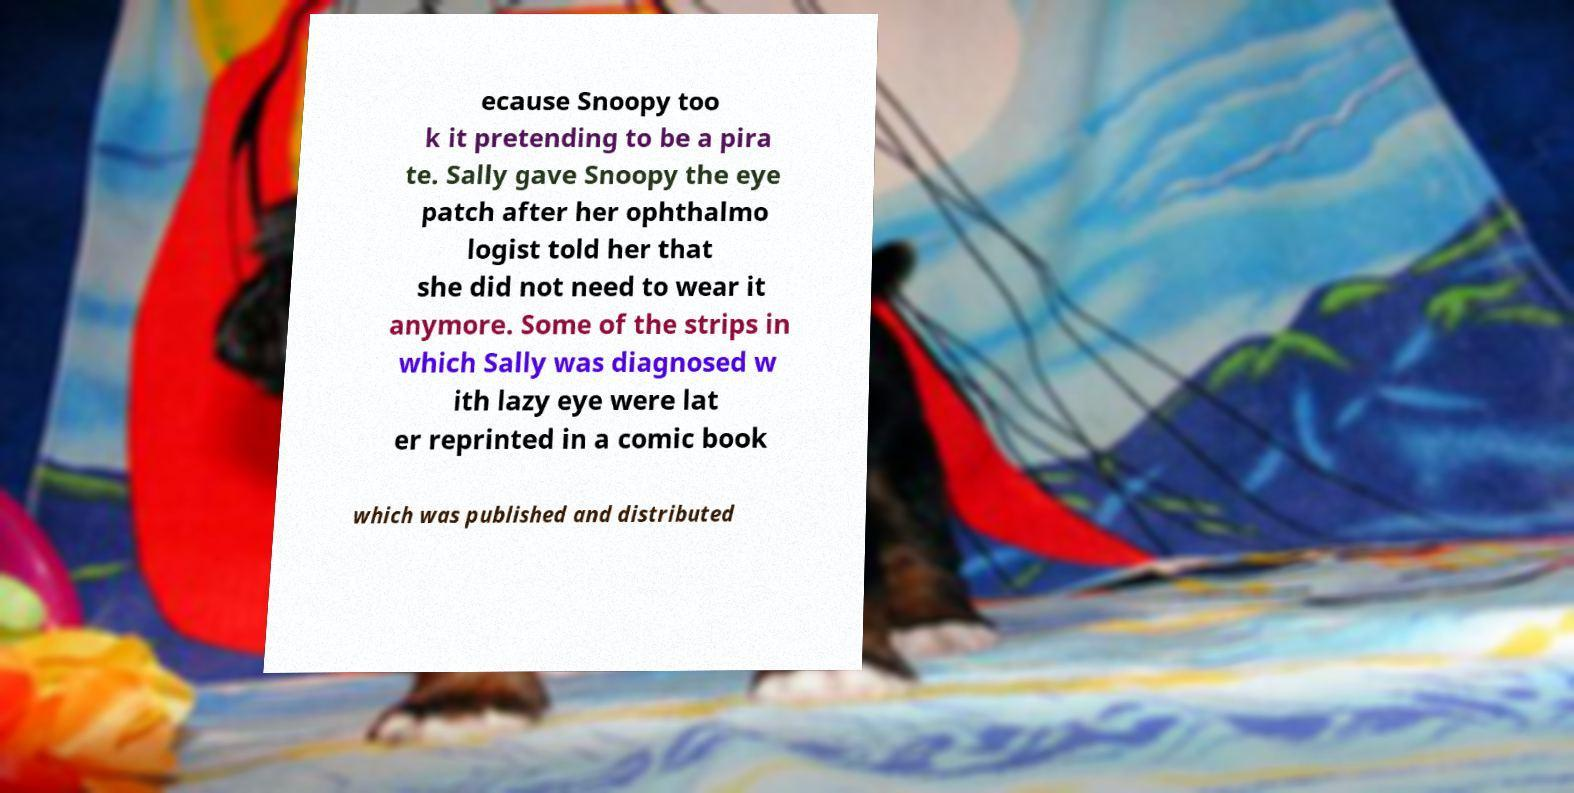Please read and relay the text visible in this image. What does it say? ecause Snoopy too k it pretending to be a pira te. Sally gave Snoopy the eye patch after her ophthalmo logist told her that she did not need to wear it anymore. Some of the strips in which Sally was diagnosed w ith lazy eye were lat er reprinted in a comic book which was published and distributed 